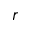<formula> <loc_0><loc_0><loc_500><loc_500>r</formula> 